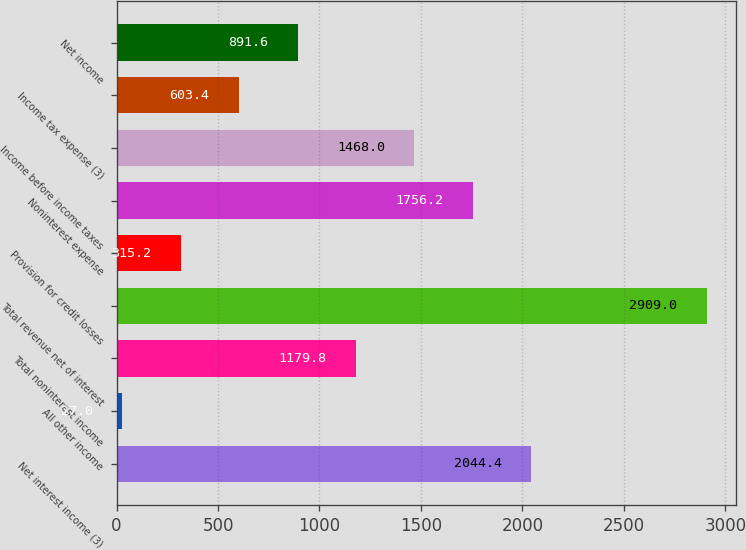Convert chart. <chart><loc_0><loc_0><loc_500><loc_500><bar_chart><fcel>Net interest income (3)<fcel>All other income<fcel>Total noninterest income<fcel>Total revenue net of interest<fcel>Provision for credit losses<fcel>Noninterest expense<fcel>Income before income taxes<fcel>Income tax expense (3)<fcel>Net income<nl><fcel>2044.4<fcel>27<fcel>1179.8<fcel>2909<fcel>315.2<fcel>1756.2<fcel>1468<fcel>603.4<fcel>891.6<nl></chart> 